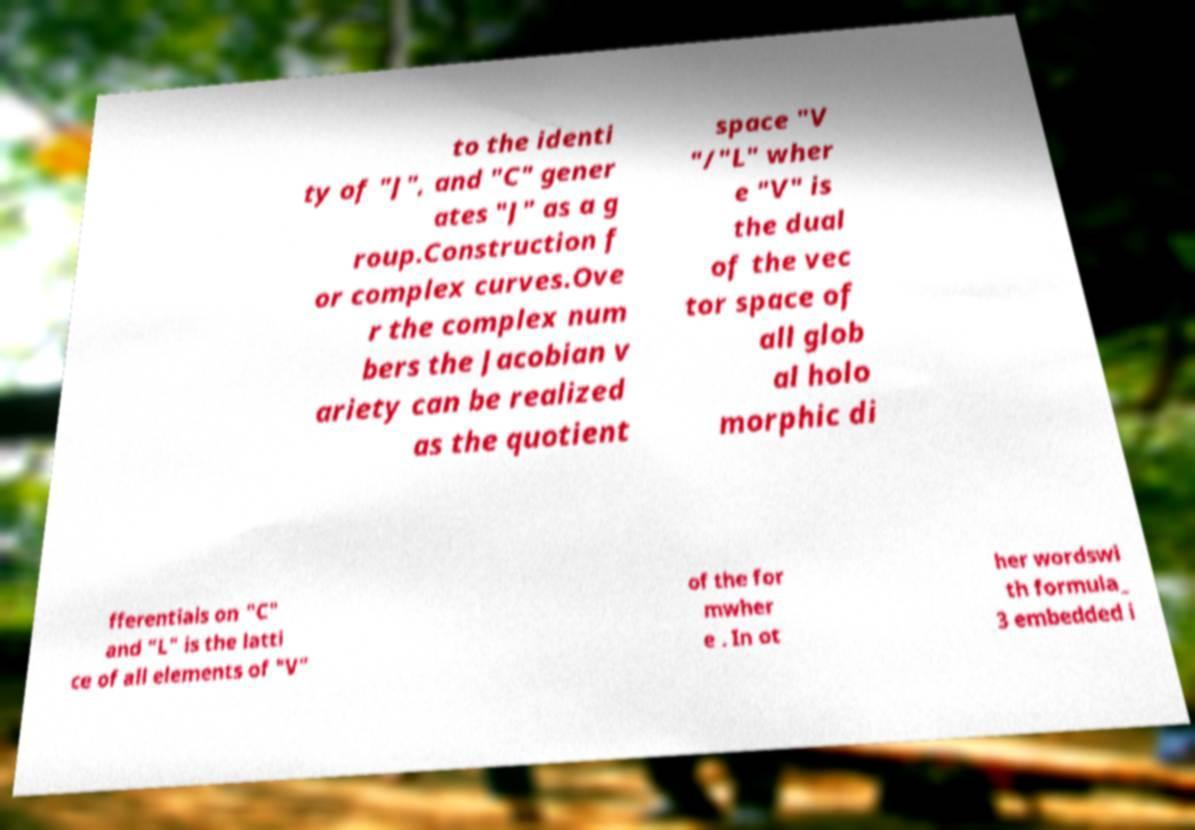Can you accurately transcribe the text from the provided image for me? to the identi ty of "J", and "C" gener ates "J" as a g roup.Construction f or complex curves.Ove r the complex num bers the Jacobian v ariety can be realized as the quotient space "V "/"L" wher e "V" is the dual of the vec tor space of all glob al holo morphic di fferentials on "C" and "L" is the latti ce of all elements of "V" of the for mwher e . In ot her wordswi th formula_ 3 embedded i 